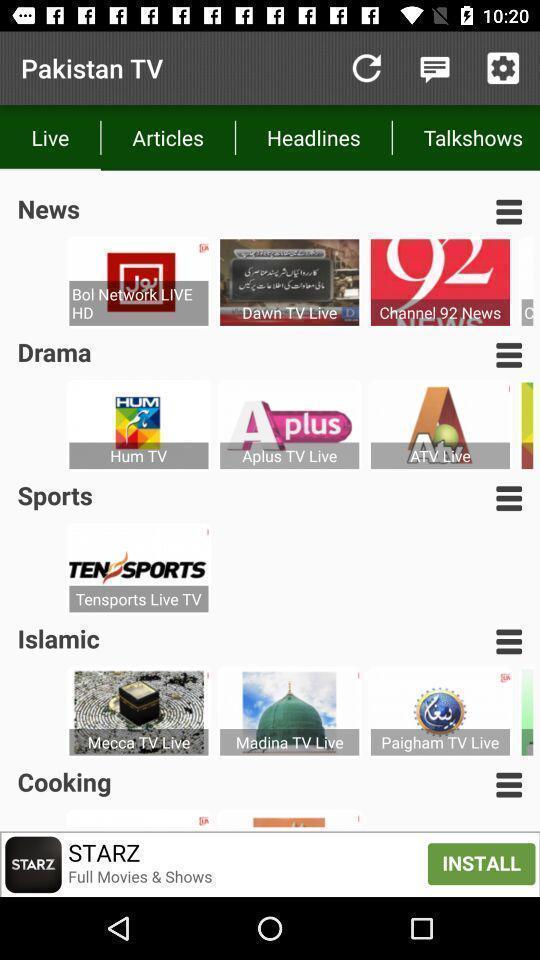Describe the visual elements of this screenshot. Page showing list of categories on news app. 